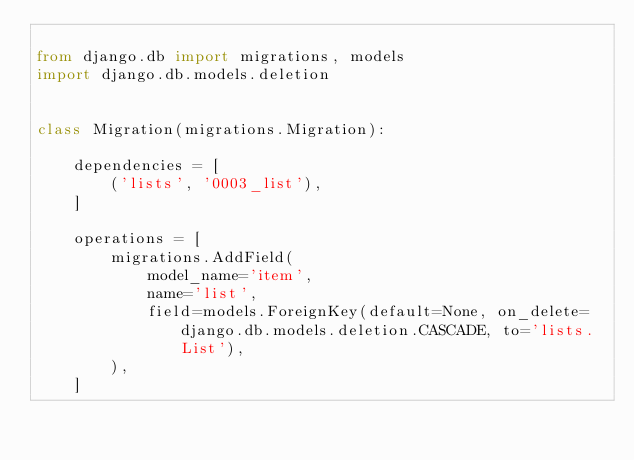Convert code to text. <code><loc_0><loc_0><loc_500><loc_500><_Python_>
from django.db import migrations, models
import django.db.models.deletion


class Migration(migrations.Migration):

    dependencies = [
        ('lists', '0003_list'),
    ]

    operations = [
        migrations.AddField(
            model_name='item',
            name='list',
            field=models.ForeignKey(default=None, on_delete=django.db.models.deletion.CASCADE, to='lists.List'),
        ),
    ]
</code> 